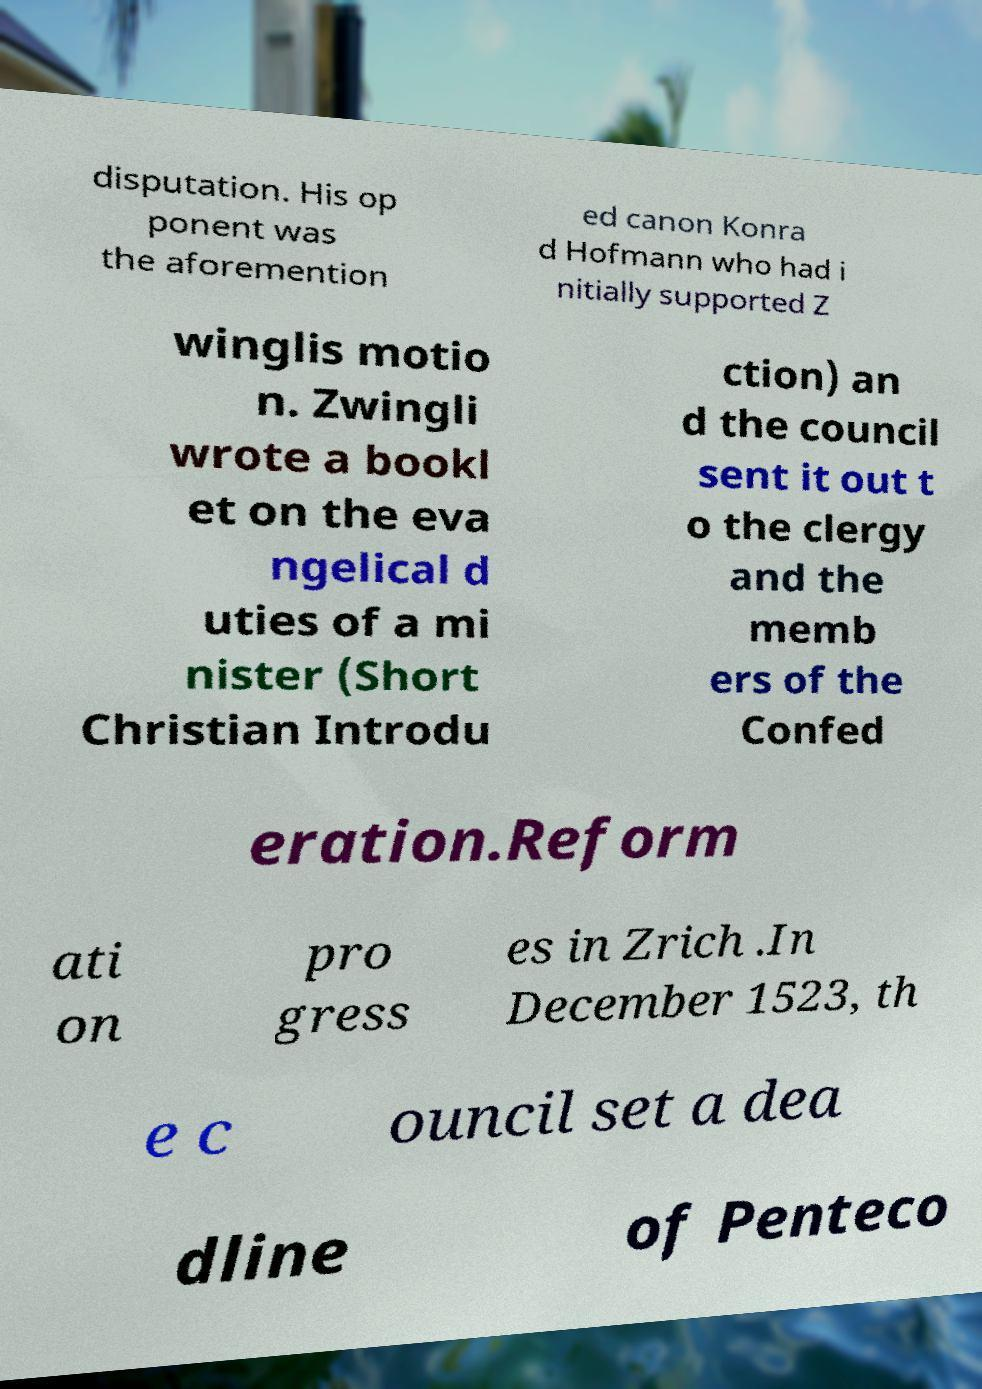Please read and relay the text visible in this image. What does it say? disputation. His op ponent was the aforemention ed canon Konra d Hofmann who had i nitially supported Z winglis motio n. Zwingli wrote a bookl et on the eva ngelical d uties of a mi nister (Short Christian Introdu ction) an d the council sent it out t o the clergy and the memb ers of the Confed eration.Reform ati on pro gress es in Zrich .In December 1523, th e c ouncil set a dea dline of Penteco 